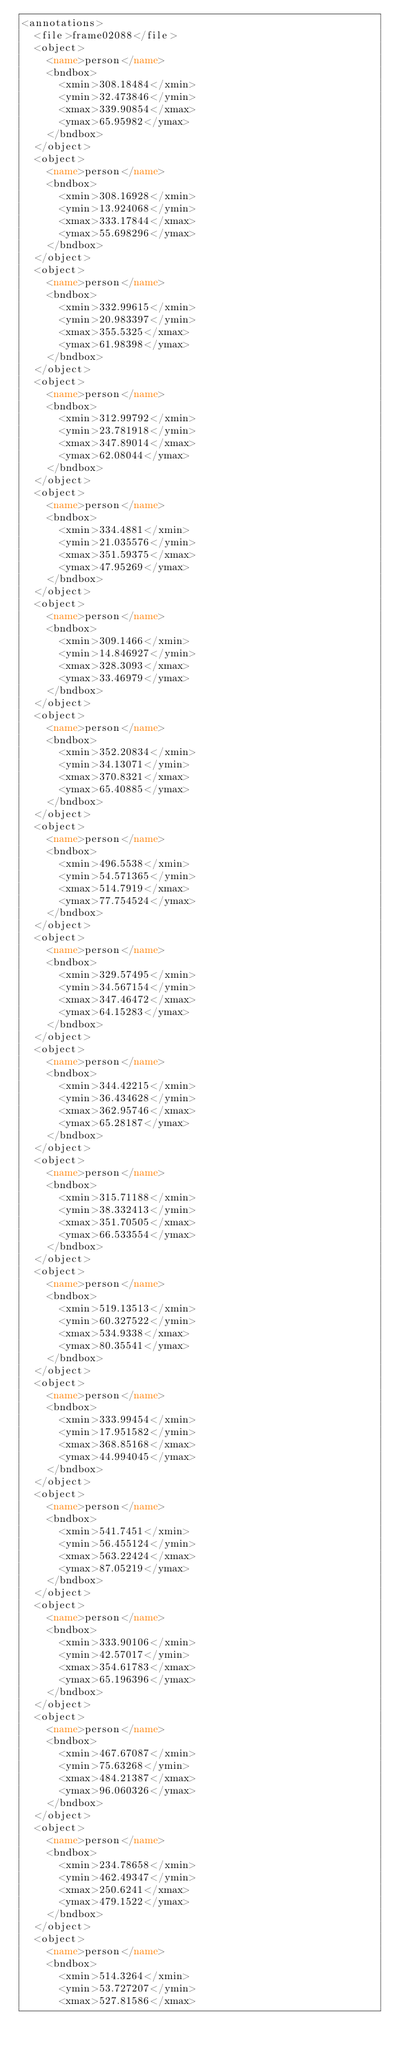Convert code to text. <code><loc_0><loc_0><loc_500><loc_500><_XML_><annotations>
  <file>frame02088</file>
  <object>
    <name>person</name>
    <bndbox>
      <xmin>308.18484</xmin>
      <ymin>32.473846</ymin>
      <xmax>339.90854</xmax>
      <ymax>65.95982</ymax>
    </bndbox>
  </object>
  <object>
    <name>person</name>
    <bndbox>
      <xmin>308.16928</xmin>
      <ymin>13.924068</ymin>
      <xmax>333.17844</xmax>
      <ymax>55.698296</ymax>
    </bndbox>
  </object>
  <object>
    <name>person</name>
    <bndbox>
      <xmin>332.99615</xmin>
      <ymin>20.983397</ymin>
      <xmax>355.5325</xmax>
      <ymax>61.98398</ymax>
    </bndbox>
  </object>
  <object>
    <name>person</name>
    <bndbox>
      <xmin>312.99792</xmin>
      <ymin>23.781918</ymin>
      <xmax>347.89014</xmax>
      <ymax>62.08044</ymax>
    </bndbox>
  </object>
  <object>
    <name>person</name>
    <bndbox>
      <xmin>334.4881</xmin>
      <ymin>21.035576</ymin>
      <xmax>351.59375</xmax>
      <ymax>47.95269</ymax>
    </bndbox>
  </object>
  <object>
    <name>person</name>
    <bndbox>
      <xmin>309.1466</xmin>
      <ymin>14.846927</ymin>
      <xmax>328.3093</xmax>
      <ymax>33.46979</ymax>
    </bndbox>
  </object>
  <object>
    <name>person</name>
    <bndbox>
      <xmin>352.20834</xmin>
      <ymin>34.13071</ymin>
      <xmax>370.8321</xmax>
      <ymax>65.40885</ymax>
    </bndbox>
  </object>
  <object>
    <name>person</name>
    <bndbox>
      <xmin>496.5538</xmin>
      <ymin>54.571365</ymin>
      <xmax>514.7919</xmax>
      <ymax>77.754524</ymax>
    </bndbox>
  </object>
  <object>
    <name>person</name>
    <bndbox>
      <xmin>329.57495</xmin>
      <ymin>34.567154</ymin>
      <xmax>347.46472</xmax>
      <ymax>64.15283</ymax>
    </bndbox>
  </object>
  <object>
    <name>person</name>
    <bndbox>
      <xmin>344.42215</xmin>
      <ymin>36.434628</ymin>
      <xmax>362.95746</xmax>
      <ymax>65.28187</ymax>
    </bndbox>
  </object>
  <object>
    <name>person</name>
    <bndbox>
      <xmin>315.71188</xmin>
      <ymin>38.332413</ymin>
      <xmax>351.70505</xmax>
      <ymax>66.533554</ymax>
    </bndbox>
  </object>
  <object>
    <name>person</name>
    <bndbox>
      <xmin>519.13513</xmin>
      <ymin>60.327522</ymin>
      <xmax>534.9338</xmax>
      <ymax>80.35541</ymax>
    </bndbox>
  </object>
  <object>
    <name>person</name>
    <bndbox>
      <xmin>333.99454</xmin>
      <ymin>17.951582</ymin>
      <xmax>368.85168</xmax>
      <ymax>44.994045</ymax>
    </bndbox>
  </object>
  <object>
    <name>person</name>
    <bndbox>
      <xmin>541.7451</xmin>
      <ymin>56.455124</ymin>
      <xmax>563.22424</xmax>
      <ymax>87.05219</ymax>
    </bndbox>
  </object>
  <object>
    <name>person</name>
    <bndbox>
      <xmin>333.90106</xmin>
      <ymin>42.57017</ymin>
      <xmax>354.61783</xmax>
      <ymax>65.196396</ymax>
    </bndbox>
  </object>
  <object>
    <name>person</name>
    <bndbox>
      <xmin>467.67087</xmin>
      <ymin>75.63268</ymin>
      <xmax>484.21387</xmax>
      <ymax>96.060326</ymax>
    </bndbox>
  </object>
  <object>
    <name>person</name>
    <bndbox>
      <xmin>234.78658</xmin>
      <ymin>462.49347</ymin>
      <xmax>250.6241</xmax>
      <ymax>479.1522</ymax>
    </bndbox>
  </object>
  <object>
    <name>person</name>
    <bndbox>
      <xmin>514.3264</xmin>
      <ymin>53.727207</ymin>
      <xmax>527.81586</xmax></code> 